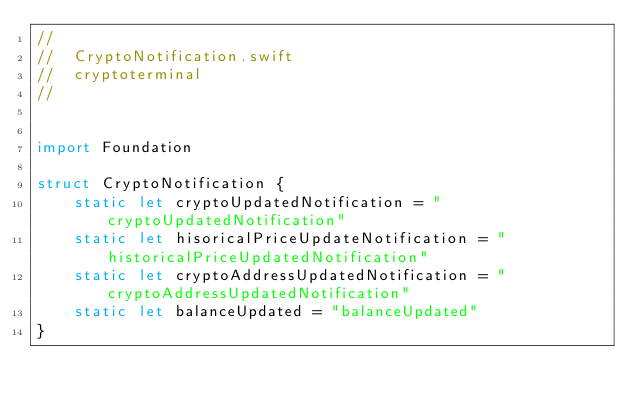Convert code to text. <code><loc_0><loc_0><loc_500><loc_500><_Swift_>//
//  CryptoNotification.swift
//  cryptoterminal
//


import Foundation

struct CryptoNotification {
    static let cryptoUpdatedNotification = "cryptoUpdatedNotification"
    static let hisoricalPriceUpdateNotification = "historicalPriceUpdatedNotification"
    static let cryptoAddressUpdatedNotification = "cryptoAddressUpdatedNotification"
    static let balanceUpdated = "balanceUpdated"
}
</code> 